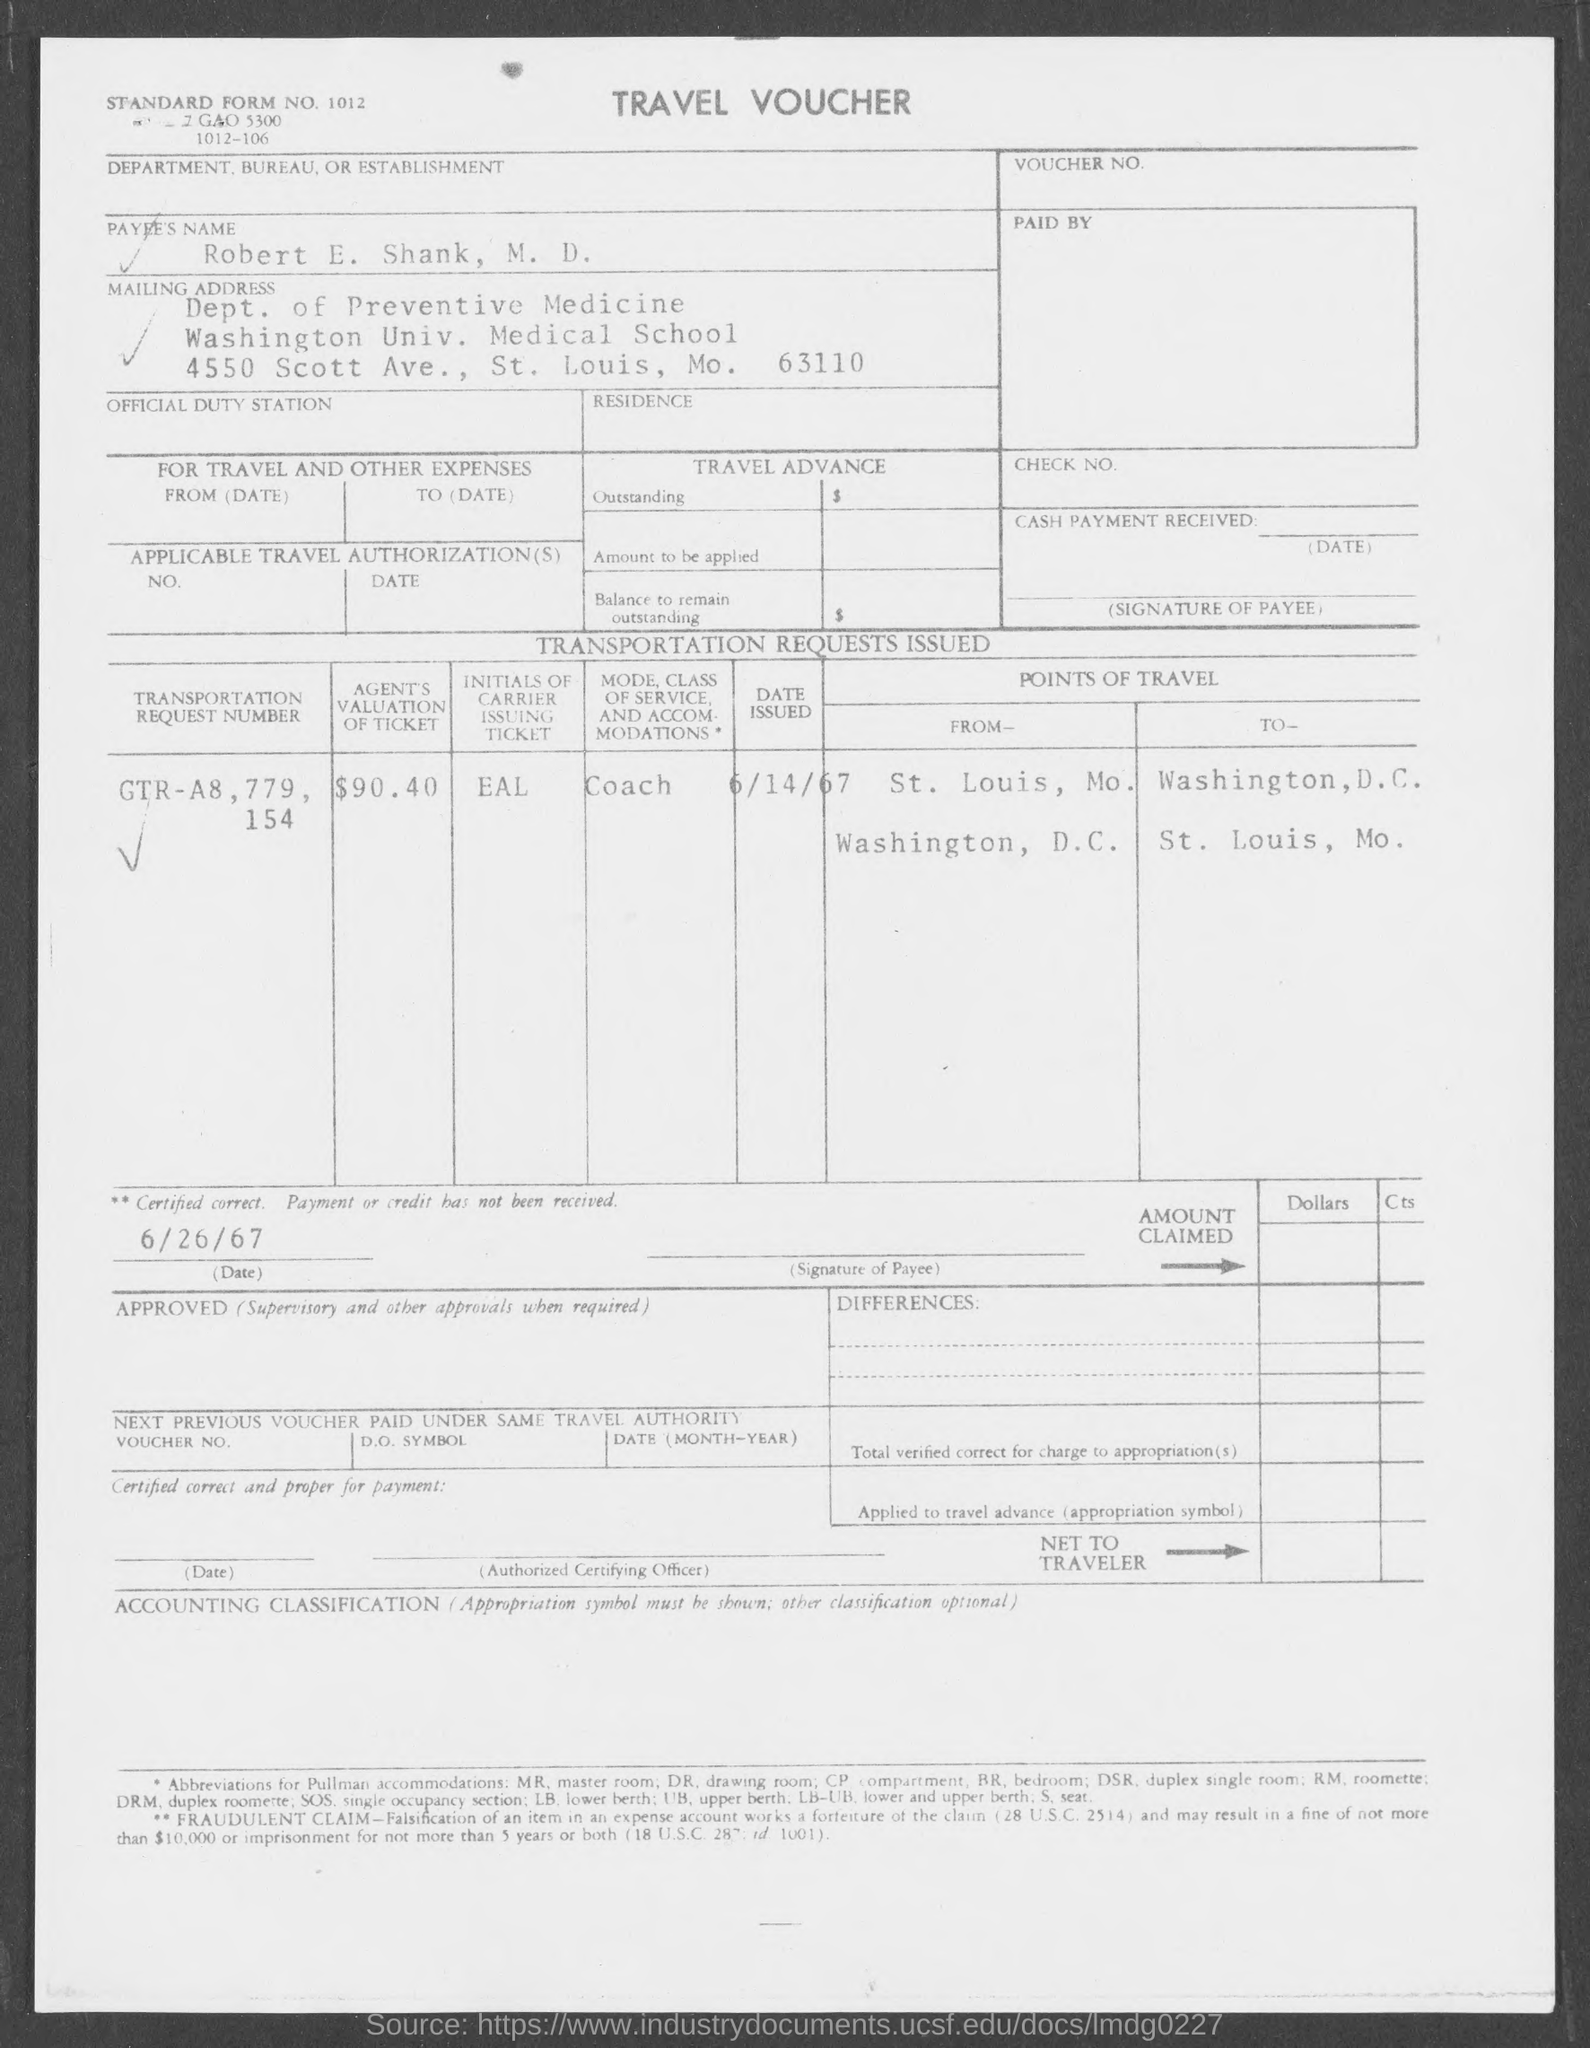What is the payee's name given in the voucher?
Your response must be concise. ROBERT E. SHANK, M.D. What is the transportation request number mentioned in the travel voucher?
Make the answer very short. GTR-A8,779,154. What is the issued date of transportation request?
Your answer should be compact. 6/14/67. What is the initials of carrier issuing ticket?
Make the answer very short. EAL. How much is the agent's valuation of ticket?
Provide a short and direct response. $90.40. 